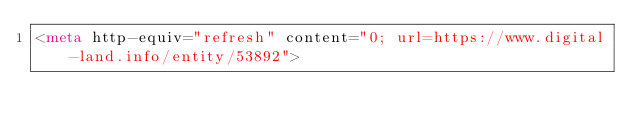Convert code to text. <code><loc_0><loc_0><loc_500><loc_500><_HTML_><meta http-equiv="refresh" content="0; url=https://www.digital-land.info/entity/53892"></code> 